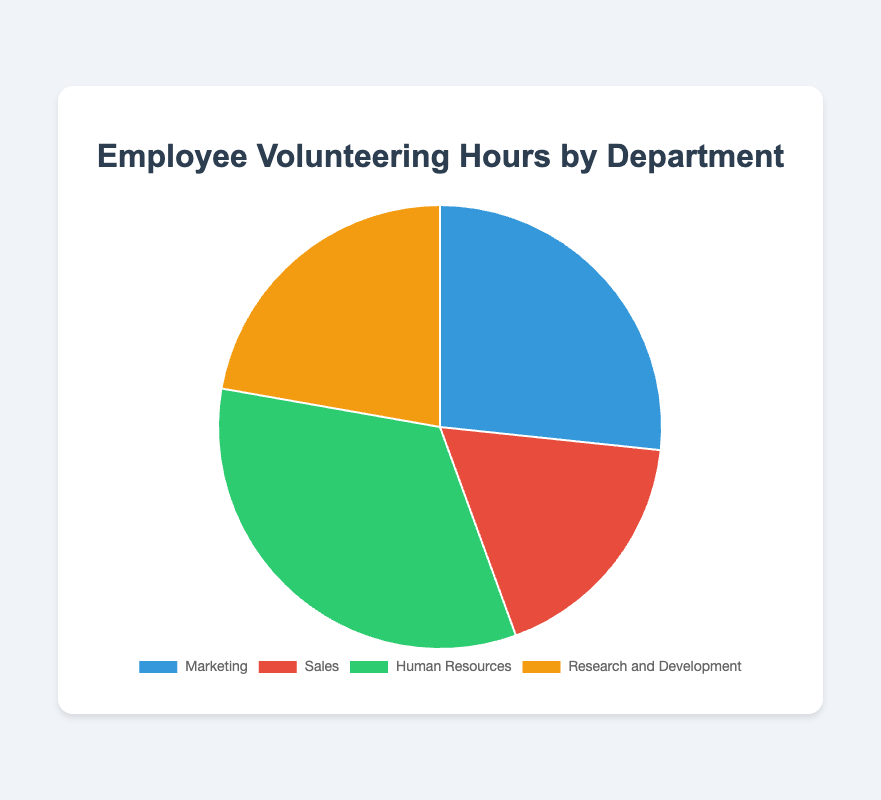What department has the highest volunteering hours? The pie chart shows that the Human Resources department has the largest segment. Referring to the data, Human Resources contributed 150 volunteering hours, which is higher than any other department.
Answer: Human Resources Which department contributed the least number of volunteering hours? The pie chart shows the smallest segment belongs to the Sales department. Referring to the data, Sales contributed 80 volunteering hours, which is the least among all departments.
Answer: Sales What is the total number of volunteering hours from all departments combined? Sum the volunteering hours from all departments: (120 + 80 + 150 + 100) = 450. So, the total is 450 hours.
Answer: 450 hours What percentage of the total volunteering hours is contributed by the Marketing department? First, calculate the total volunteering hours (450 hours). Then, find the percentage contribution of Marketing: (120 / 450) * 100 ≈ 26.67%.
Answer: 26.67% How many more volunteering hours did Human Resources contribute compared to Sales? Subtract the volunteering hours of Sales from Human Resources: 150 - 80 = 70. Human Resources contributed 70 more hours than Sales.
Answer: 70 hours What is the average number of volunteering hours per department? The total volunteering hours are 450, and there are 4 departments. So, the average number of hours per department: 450 / 4 = 112.5 hours.
Answer: 112.5 hours Is the Research and Development department's volunteering hours greater than the average volunteering hours of the departments? First, find the average number of volunteering hours per department: 450 / 4 = 112.5 hours. The Research and Development department contributed 100 hours, which is less than the average.
Answer: No Which two departments together contribute the same or similar amount of volunteering hours as the Human Resources department? Human Resources contributed 150 hours. Adding Marketing and Sales: 120 + 80 = 200 (too high). Adding Sales and Research and Development: 80 + 100 = 180 (too high). Adding Marketing and Research and Development: 120 + 100 = 220 (too high). So, no two departments together contribute exactly equal to Human Resources.
Answer: No two departments What color represents the Sales department in the pie chart? The pie chart uses distinct colors for each department. Referring to the visual information, the Sales department is represented by the red segment.
Answer: Red 